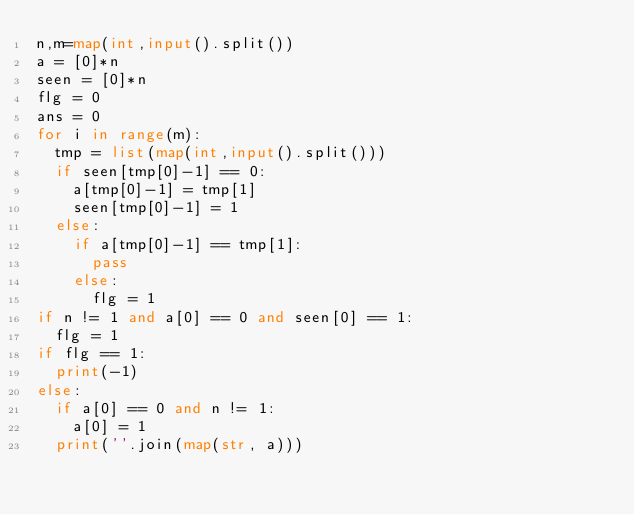Convert code to text. <code><loc_0><loc_0><loc_500><loc_500><_Python_>n,m=map(int,input().split())
a = [0]*n
seen = [0]*n
flg = 0
ans = 0
for i in range(m):
  tmp = list(map(int,input().split()))
  if seen[tmp[0]-1] == 0:
    a[tmp[0]-1] = tmp[1]
    seen[tmp[0]-1] = 1
  else:
    if a[tmp[0]-1] == tmp[1]:
      pass
    else:
      flg = 1
if n != 1 and a[0] == 0 and seen[0] == 1:
  flg = 1
if flg == 1:
  print(-1)
else:
  if a[0] == 0 and n != 1:
    a[0] = 1
  print(''.join(map(str, a)))</code> 